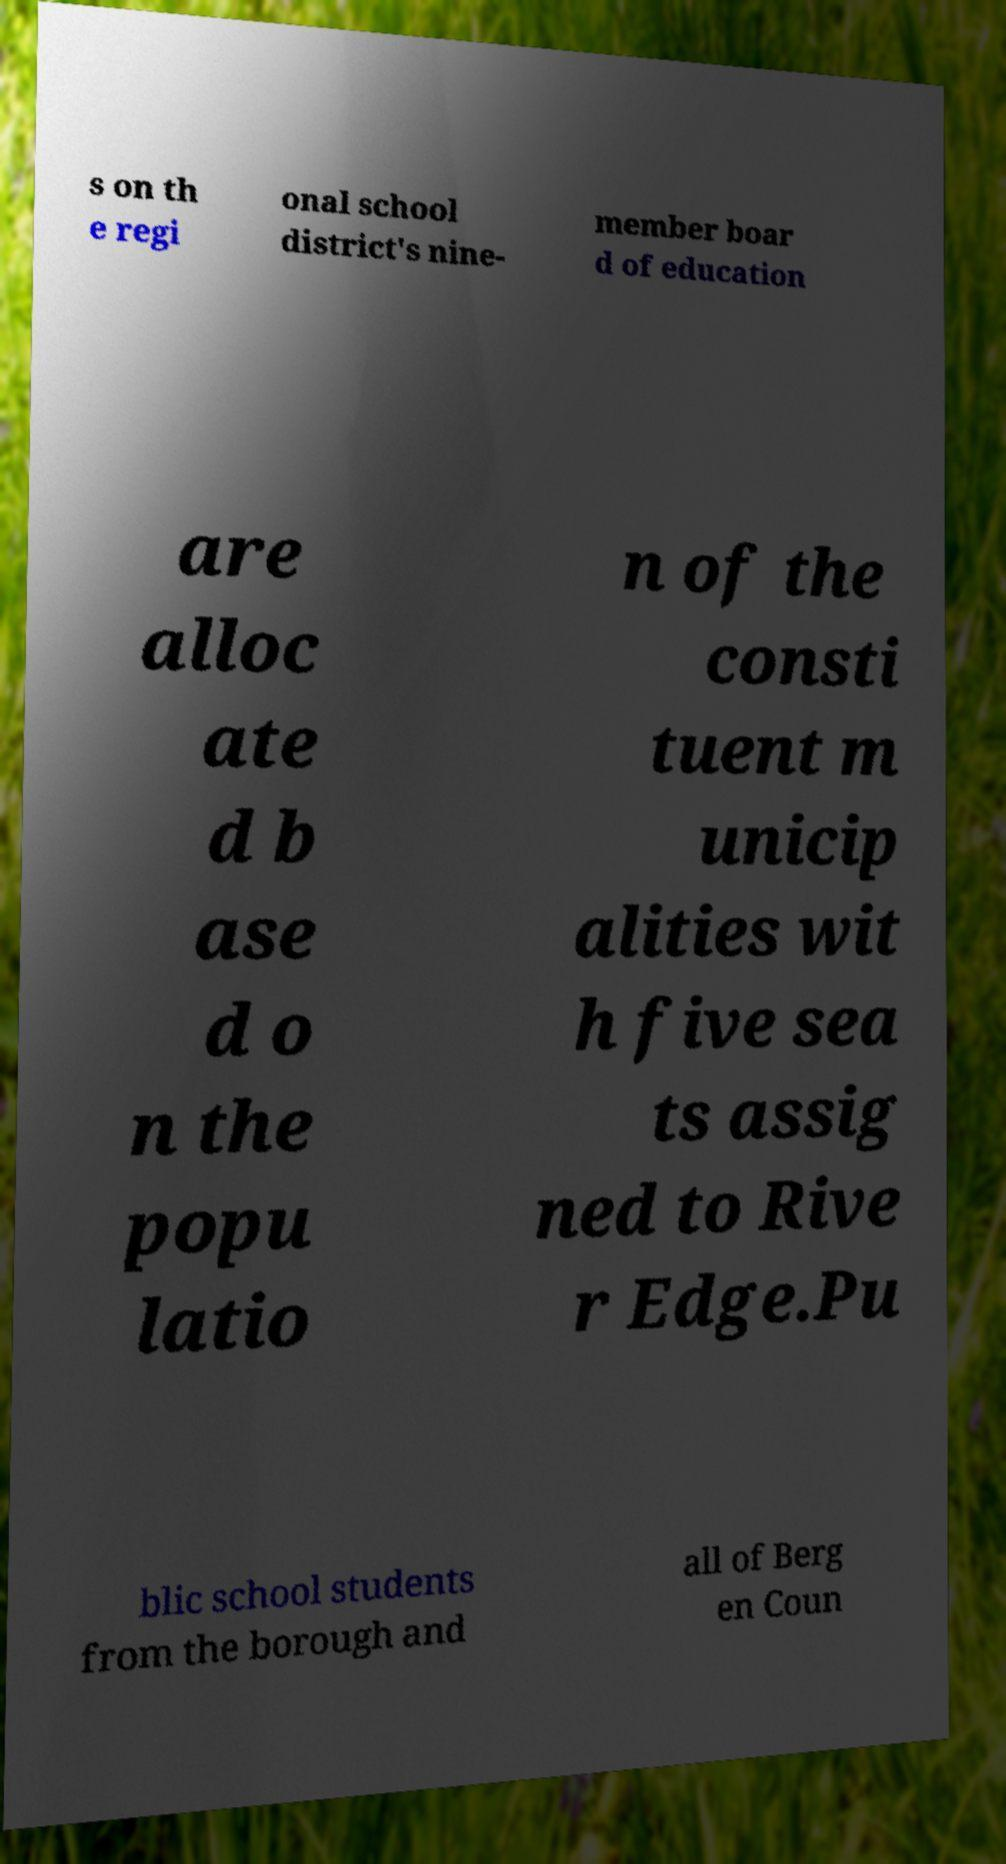Could you assist in decoding the text presented in this image and type it out clearly? s on th e regi onal school district's nine- member boar d of education are alloc ate d b ase d o n the popu latio n of the consti tuent m unicip alities wit h five sea ts assig ned to Rive r Edge.Pu blic school students from the borough and all of Berg en Coun 